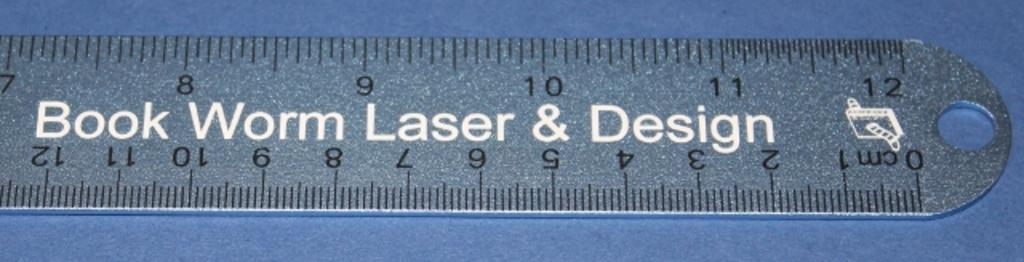<image>
Give a short and clear explanation of the subsequent image. A ruler that measures in inches and centimeters with the text book worm laser and design in the center. 